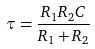<formula> <loc_0><loc_0><loc_500><loc_500>\tau = \frac { R _ { 1 } R _ { 2 } C } { R _ { 1 } + R _ { 2 } }</formula> 